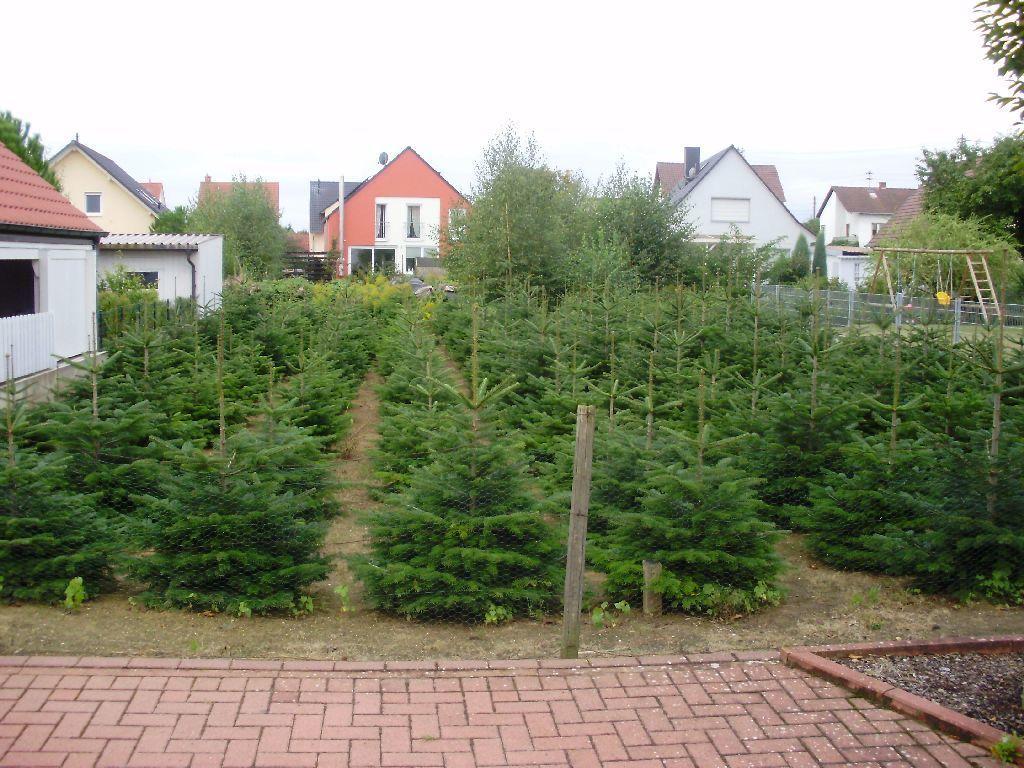Can you describe this image briefly? In this image we can see some plants on the ground and there are some houses in the background. There are some trees and we can see the sky at the top. 